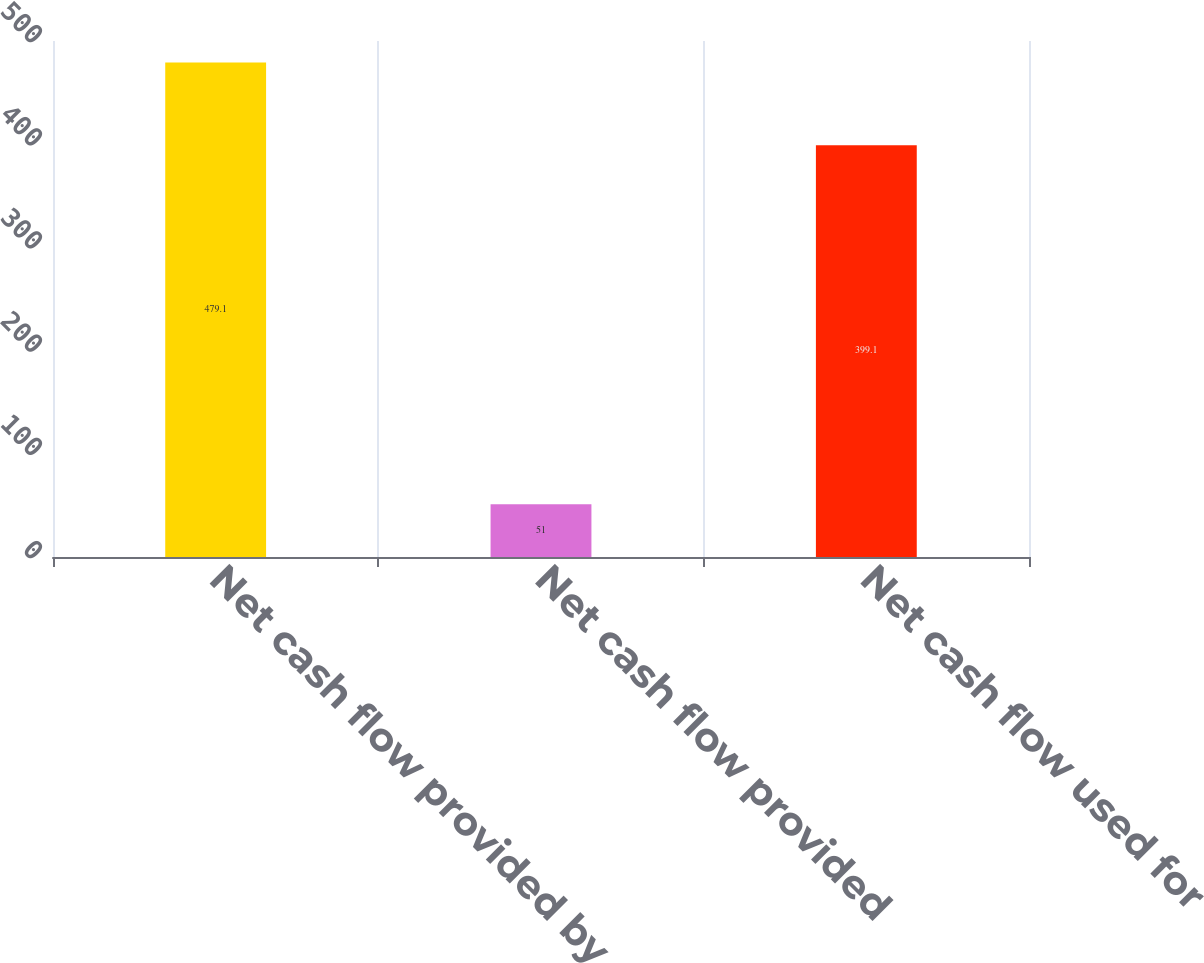Convert chart. <chart><loc_0><loc_0><loc_500><loc_500><bar_chart><fcel>Net cash flow provided by<fcel>Net cash flow provided<fcel>Net cash flow used for<nl><fcel>479.1<fcel>51<fcel>399.1<nl></chart> 